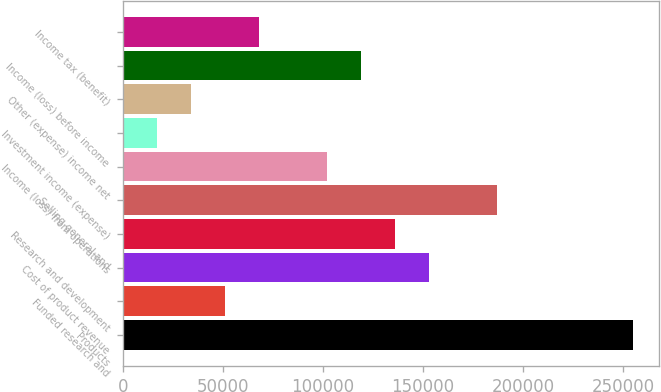Convert chart to OTSL. <chart><loc_0><loc_0><loc_500><loc_500><bar_chart><fcel>Products<fcel>Funded research and<fcel>Cost of product revenue<fcel>Research and development<fcel>Selling general and<fcel>Income (loss) from operations<fcel>Investment income (expense)<fcel>Other (expense) income net<fcel>Income (loss) before income<fcel>Income tax (benefit)<nl><fcel>254998<fcel>51000<fcel>152999<fcel>135999<fcel>186999<fcel>102000<fcel>17000.2<fcel>34000.1<fcel>118999<fcel>67999.8<nl></chart> 